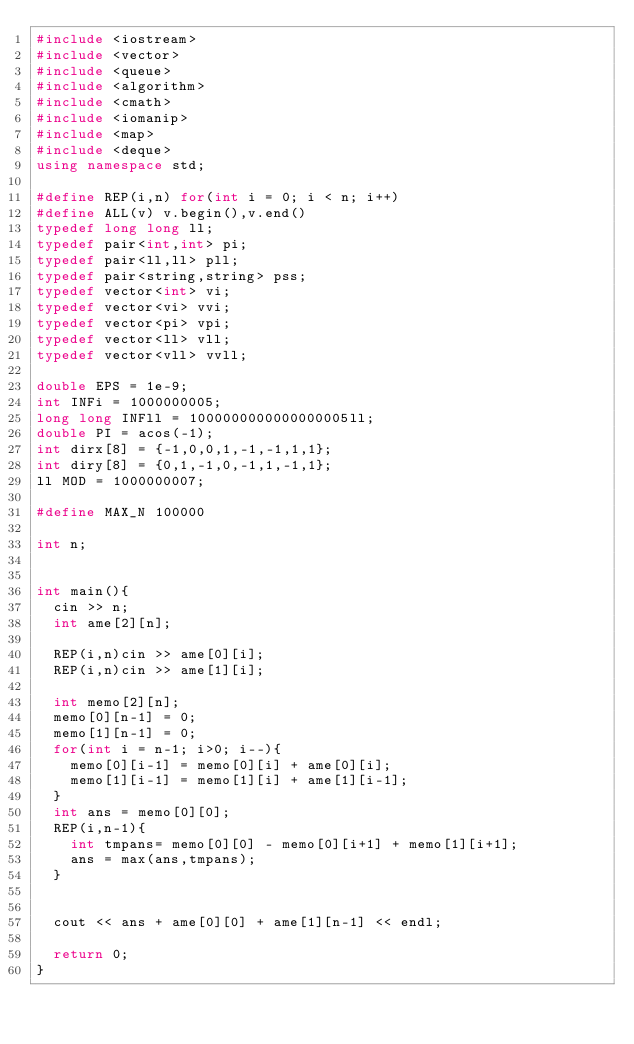<code> <loc_0><loc_0><loc_500><loc_500><_C++_>#include <iostream>
#include <vector>
#include <queue>
#include <algorithm>
#include <cmath>
#include <iomanip>
#include <map>
#include <deque>
using namespace std;

#define REP(i,n) for(int i = 0; i < n; i++)
#define ALL(v) v.begin(),v.end()
typedef long long ll;
typedef pair<int,int> pi;
typedef pair<ll,ll> pll;
typedef pair<string,string> pss;
typedef vector<int> vi;
typedef vector<vi> vvi;
typedef vector<pi> vpi;
typedef vector<ll> vll;
typedef vector<vll> vvll;

double EPS = 1e-9;
int INFi = 1000000005;
long long INFll = 1000000000000000005ll;
double PI = acos(-1);
int dirx[8] = {-1,0,0,1,-1,-1,1,1};
int diry[8] = {0,1,-1,0,-1,1,-1,1};
ll MOD = 1000000007;

#define MAX_N 100000

int n;


int main(){
  cin >> n;
  int ame[2][n];

  REP(i,n)cin >> ame[0][i];
  REP(i,n)cin >> ame[1][i];

  int memo[2][n];
  memo[0][n-1] = 0;
  memo[1][n-1] = 0;
  for(int i = n-1; i>0; i--){
    memo[0][i-1] = memo[0][i] + ame[0][i];
    memo[1][i-1] = memo[1][i] + ame[1][i-1];
  }
  int ans = memo[0][0];
  REP(i,n-1){
    int tmpans= memo[0][0] - memo[0][i+1] + memo[1][i+1];
    ans = max(ans,tmpans);
  }


  cout << ans + ame[0][0] + ame[1][n-1] << endl;

  return 0;
}
</code> 